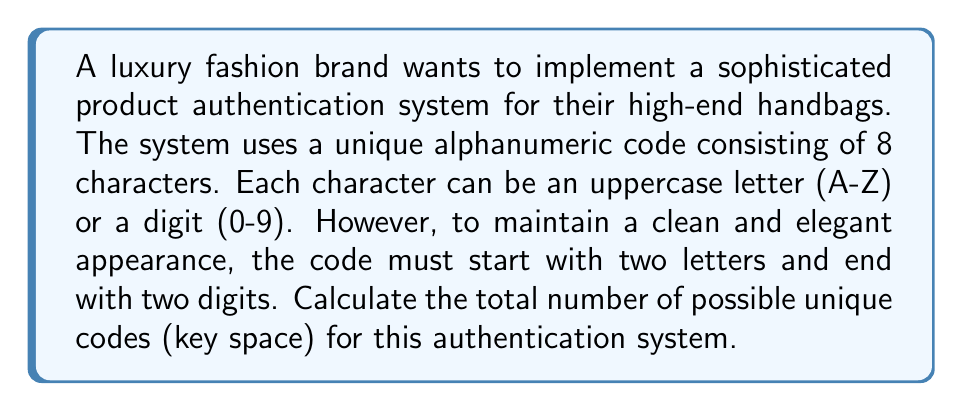Give your solution to this math problem. Let's break this down step-by-step:

1) The code structure is: LL???DD, where L represents a letter, ? represents either a letter or digit, and D represents a digit.

2) For the first two positions (LL):
   - There are 26 choices for each letter
   - Total combinations: $26 \times 26 = 26^2$

3) For the last two positions (DD):
   - There are 10 choices for each digit
   - Total combinations: $10 \times 10 = 10^2$

4) For the middle four positions (????):
   - Each position can be either a letter (26 choices) or a digit (10 choices)
   - Total choices per position: $26 + 10 = 36$
   - For all four positions: $36^4$

5) Applying the multiplication principle, we multiply all these possibilities:

   $$\text{Key Space} = 26^2 \times 36^4 \times 10^2$$

6) Calculate the result:
   $$\begin{align}
   \text{Key Space} &= 676 \times 1,679,616 \times 100 \\
   &= 113,481,441,600
   \end{align}$$

This results in a key space of over 113 billion unique codes, providing a robust authentication system for the luxury brand's products.
Answer: 113,481,441,600 